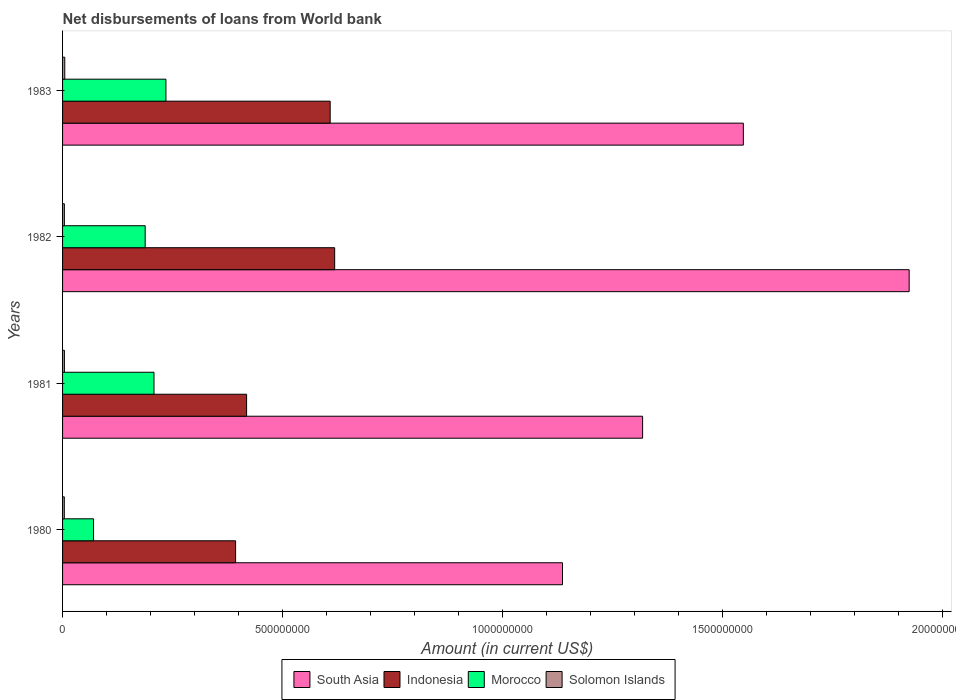What is the amount of loan disbursed from World Bank in Indonesia in 1980?
Provide a short and direct response. 3.93e+08. Across all years, what is the maximum amount of loan disbursed from World Bank in South Asia?
Ensure brevity in your answer.  1.92e+09. Across all years, what is the minimum amount of loan disbursed from World Bank in Indonesia?
Give a very brief answer. 3.93e+08. In which year was the amount of loan disbursed from World Bank in Morocco minimum?
Provide a short and direct response. 1980. What is the total amount of loan disbursed from World Bank in Morocco in the graph?
Give a very brief answer. 7.01e+08. What is the difference between the amount of loan disbursed from World Bank in Solomon Islands in 1981 and that in 1982?
Your answer should be compact. 6.50e+04. What is the difference between the amount of loan disbursed from World Bank in Morocco in 1981 and the amount of loan disbursed from World Bank in South Asia in 1980?
Provide a short and direct response. -9.28e+08. What is the average amount of loan disbursed from World Bank in South Asia per year?
Your response must be concise. 1.48e+09. In the year 1981, what is the difference between the amount of loan disbursed from World Bank in Indonesia and amount of loan disbursed from World Bank in South Asia?
Provide a succinct answer. -9.00e+08. What is the ratio of the amount of loan disbursed from World Bank in Solomon Islands in 1980 to that in 1982?
Provide a short and direct response. 0.96. Is the amount of loan disbursed from World Bank in Morocco in 1980 less than that in 1981?
Your response must be concise. Yes. Is the difference between the amount of loan disbursed from World Bank in Indonesia in 1981 and 1982 greater than the difference between the amount of loan disbursed from World Bank in South Asia in 1981 and 1982?
Provide a short and direct response. Yes. What is the difference between the highest and the second highest amount of loan disbursed from World Bank in Indonesia?
Ensure brevity in your answer.  1.02e+07. What is the difference between the highest and the lowest amount of loan disbursed from World Bank in South Asia?
Offer a terse response. 7.88e+08. What does the 4th bar from the top in 1983 represents?
Provide a short and direct response. South Asia. What does the 4th bar from the bottom in 1982 represents?
Provide a succinct answer. Solomon Islands. Is it the case that in every year, the sum of the amount of loan disbursed from World Bank in Solomon Islands and amount of loan disbursed from World Bank in Morocco is greater than the amount of loan disbursed from World Bank in South Asia?
Ensure brevity in your answer.  No. How many years are there in the graph?
Give a very brief answer. 4. Where does the legend appear in the graph?
Keep it short and to the point. Bottom center. What is the title of the graph?
Offer a terse response. Net disbursements of loans from World bank. Does "Sub-Saharan Africa (all income levels)" appear as one of the legend labels in the graph?
Your answer should be compact. No. What is the Amount (in current US$) of South Asia in 1980?
Give a very brief answer. 1.14e+09. What is the Amount (in current US$) of Indonesia in 1980?
Your answer should be very brief. 3.93e+08. What is the Amount (in current US$) of Morocco in 1980?
Provide a short and direct response. 7.03e+07. What is the Amount (in current US$) in Solomon Islands in 1980?
Make the answer very short. 3.96e+06. What is the Amount (in current US$) in South Asia in 1981?
Offer a very short reply. 1.32e+09. What is the Amount (in current US$) in Indonesia in 1981?
Provide a succinct answer. 4.18e+08. What is the Amount (in current US$) of Morocco in 1981?
Your response must be concise. 2.08e+08. What is the Amount (in current US$) of Solomon Islands in 1981?
Your response must be concise. 4.18e+06. What is the Amount (in current US$) of South Asia in 1982?
Your answer should be very brief. 1.92e+09. What is the Amount (in current US$) in Indonesia in 1982?
Make the answer very short. 6.18e+08. What is the Amount (in current US$) of Morocco in 1982?
Keep it short and to the point. 1.88e+08. What is the Amount (in current US$) in Solomon Islands in 1982?
Make the answer very short. 4.12e+06. What is the Amount (in current US$) in South Asia in 1983?
Your answer should be very brief. 1.55e+09. What is the Amount (in current US$) of Indonesia in 1983?
Your answer should be compact. 6.08e+08. What is the Amount (in current US$) of Morocco in 1983?
Keep it short and to the point. 2.35e+08. What is the Amount (in current US$) in Solomon Islands in 1983?
Provide a short and direct response. 5.01e+06. Across all years, what is the maximum Amount (in current US$) of South Asia?
Keep it short and to the point. 1.92e+09. Across all years, what is the maximum Amount (in current US$) in Indonesia?
Make the answer very short. 6.18e+08. Across all years, what is the maximum Amount (in current US$) in Morocco?
Offer a terse response. 2.35e+08. Across all years, what is the maximum Amount (in current US$) in Solomon Islands?
Ensure brevity in your answer.  5.01e+06. Across all years, what is the minimum Amount (in current US$) of South Asia?
Provide a succinct answer. 1.14e+09. Across all years, what is the minimum Amount (in current US$) of Indonesia?
Provide a short and direct response. 3.93e+08. Across all years, what is the minimum Amount (in current US$) in Morocco?
Ensure brevity in your answer.  7.03e+07. Across all years, what is the minimum Amount (in current US$) of Solomon Islands?
Your answer should be compact. 3.96e+06. What is the total Amount (in current US$) of South Asia in the graph?
Provide a short and direct response. 5.93e+09. What is the total Amount (in current US$) of Indonesia in the graph?
Give a very brief answer. 2.04e+09. What is the total Amount (in current US$) of Morocco in the graph?
Keep it short and to the point. 7.01e+08. What is the total Amount (in current US$) in Solomon Islands in the graph?
Keep it short and to the point. 1.73e+07. What is the difference between the Amount (in current US$) in South Asia in 1980 and that in 1981?
Ensure brevity in your answer.  -1.82e+08. What is the difference between the Amount (in current US$) of Indonesia in 1980 and that in 1981?
Give a very brief answer. -2.49e+07. What is the difference between the Amount (in current US$) of Morocco in 1980 and that in 1981?
Ensure brevity in your answer.  -1.37e+08. What is the difference between the Amount (in current US$) of Solomon Islands in 1980 and that in 1981?
Make the answer very short. -2.23e+05. What is the difference between the Amount (in current US$) of South Asia in 1980 and that in 1982?
Keep it short and to the point. -7.88e+08. What is the difference between the Amount (in current US$) of Indonesia in 1980 and that in 1982?
Give a very brief answer. -2.25e+08. What is the difference between the Amount (in current US$) of Morocco in 1980 and that in 1982?
Offer a very short reply. -1.17e+08. What is the difference between the Amount (in current US$) in Solomon Islands in 1980 and that in 1982?
Ensure brevity in your answer.  -1.58e+05. What is the difference between the Amount (in current US$) in South Asia in 1980 and that in 1983?
Provide a short and direct response. -4.11e+08. What is the difference between the Amount (in current US$) in Indonesia in 1980 and that in 1983?
Make the answer very short. -2.15e+08. What is the difference between the Amount (in current US$) of Morocco in 1980 and that in 1983?
Your answer should be compact. -1.65e+08. What is the difference between the Amount (in current US$) of Solomon Islands in 1980 and that in 1983?
Provide a short and direct response. -1.05e+06. What is the difference between the Amount (in current US$) of South Asia in 1981 and that in 1982?
Offer a very short reply. -6.06e+08. What is the difference between the Amount (in current US$) of Indonesia in 1981 and that in 1982?
Offer a terse response. -2.00e+08. What is the difference between the Amount (in current US$) of Morocco in 1981 and that in 1982?
Offer a terse response. 2.01e+07. What is the difference between the Amount (in current US$) in Solomon Islands in 1981 and that in 1982?
Offer a terse response. 6.50e+04. What is the difference between the Amount (in current US$) in South Asia in 1981 and that in 1983?
Offer a very short reply. -2.29e+08. What is the difference between the Amount (in current US$) in Indonesia in 1981 and that in 1983?
Your response must be concise. -1.90e+08. What is the difference between the Amount (in current US$) of Morocco in 1981 and that in 1983?
Give a very brief answer. -2.71e+07. What is the difference between the Amount (in current US$) in Solomon Islands in 1981 and that in 1983?
Offer a very short reply. -8.31e+05. What is the difference between the Amount (in current US$) in South Asia in 1982 and that in 1983?
Make the answer very short. 3.77e+08. What is the difference between the Amount (in current US$) in Indonesia in 1982 and that in 1983?
Provide a short and direct response. 1.02e+07. What is the difference between the Amount (in current US$) of Morocco in 1982 and that in 1983?
Your answer should be compact. -4.72e+07. What is the difference between the Amount (in current US$) in Solomon Islands in 1982 and that in 1983?
Give a very brief answer. -8.96e+05. What is the difference between the Amount (in current US$) in South Asia in 1980 and the Amount (in current US$) in Indonesia in 1981?
Give a very brief answer. 7.18e+08. What is the difference between the Amount (in current US$) of South Asia in 1980 and the Amount (in current US$) of Morocco in 1981?
Provide a short and direct response. 9.28e+08. What is the difference between the Amount (in current US$) of South Asia in 1980 and the Amount (in current US$) of Solomon Islands in 1981?
Offer a terse response. 1.13e+09. What is the difference between the Amount (in current US$) in Indonesia in 1980 and the Amount (in current US$) in Morocco in 1981?
Make the answer very short. 1.85e+08. What is the difference between the Amount (in current US$) of Indonesia in 1980 and the Amount (in current US$) of Solomon Islands in 1981?
Your answer should be very brief. 3.89e+08. What is the difference between the Amount (in current US$) in Morocco in 1980 and the Amount (in current US$) in Solomon Islands in 1981?
Offer a terse response. 6.62e+07. What is the difference between the Amount (in current US$) of South Asia in 1980 and the Amount (in current US$) of Indonesia in 1982?
Offer a very short reply. 5.18e+08. What is the difference between the Amount (in current US$) of South Asia in 1980 and the Amount (in current US$) of Morocco in 1982?
Your answer should be compact. 9.48e+08. What is the difference between the Amount (in current US$) in South Asia in 1980 and the Amount (in current US$) in Solomon Islands in 1982?
Your answer should be very brief. 1.13e+09. What is the difference between the Amount (in current US$) of Indonesia in 1980 and the Amount (in current US$) of Morocco in 1982?
Give a very brief answer. 2.06e+08. What is the difference between the Amount (in current US$) of Indonesia in 1980 and the Amount (in current US$) of Solomon Islands in 1982?
Give a very brief answer. 3.89e+08. What is the difference between the Amount (in current US$) of Morocco in 1980 and the Amount (in current US$) of Solomon Islands in 1982?
Your response must be concise. 6.62e+07. What is the difference between the Amount (in current US$) in South Asia in 1980 and the Amount (in current US$) in Indonesia in 1983?
Keep it short and to the point. 5.28e+08. What is the difference between the Amount (in current US$) of South Asia in 1980 and the Amount (in current US$) of Morocco in 1983?
Your answer should be compact. 9.01e+08. What is the difference between the Amount (in current US$) in South Asia in 1980 and the Amount (in current US$) in Solomon Islands in 1983?
Provide a short and direct response. 1.13e+09. What is the difference between the Amount (in current US$) of Indonesia in 1980 and the Amount (in current US$) of Morocco in 1983?
Make the answer very short. 1.58e+08. What is the difference between the Amount (in current US$) of Indonesia in 1980 and the Amount (in current US$) of Solomon Islands in 1983?
Ensure brevity in your answer.  3.88e+08. What is the difference between the Amount (in current US$) of Morocco in 1980 and the Amount (in current US$) of Solomon Islands in 1983?
Keep it short and to the point. 6.53e+07. What is the difference between the Amount (in current US$) in South Asia in 1981 and the Amount (in current US$) in Indonesia in 1982?
Give a very brief answer. 7.00e+08. What is the difference between the Amount (in current US$) of South Asia in 1981 and the Amount (in current US$) of Morocco in 1982?
Your answer should be very brief. 1.13e+09. What is the difference between the Amount (in current US$) of South Asia in 1981 and the Amount (in current US$) of Solomon Islands in 1982?
Keep it short and to the point. 1.31e+09. What is the difference between the Amount (in current US$) in Indonesia in 1981 and the Amount (in current US$) in Morocco in 1982?
Your answer should be compact. 2.30e+08. What is the difference between the Amount (in current US$) in Indonesia in 1981 and the Amount (in current US$) in Solomon Islands in 1982?
Provide a short and direct response. 4.14e+08. What is the difference between the Amount (in current US$) in Morocco in 1981 and the Amount (in current US$) in Solomon Islands in 1982?
Provide a succinct answer. 2.04e+08. What is the difference between the Amount (in current US$) in South Asia in 1981 and the Amount (in current US$) in Indonesia in 1983?
Offer a terse response. 7.10e+08. What is the difference between the Amount (in current US$) in South Asia in 1981 and the Amount (in current US$) in Morocco in 1983?
Make the answer very short. 1.08e+09. What is the difference between the Amount (in current US$) of South Asia in 1981 and the Amount (in current US$) of Solomon Islands in 1983?
Make the answer very short. 1.31e+09. What is the difference between the Amount (in current US$) in Indonesia in 1981 and the Amount (in current US$) in Morocco in 1983?
Keep it short and to the point. 1.83e+08. What is the difference between the Amount (in current US$) of Indonesia in 1981 and the Amount (in current US$) of Solomon Islands in 1983?
Your answer should be compact. 4.13e+08. What is the difference between the Amount (in current US$) in Morocco in 1981 and the Amount (in current US$) in Solomon Islands in 1983?
Offer a terse response. 2.03e+08. What is the difference between the Amount (in current US$) of South Asia in 1982 and the Amount (in current US$) of Indonesia in 1983?
Your answer should be very brief. 1.32e+09. What is the difference between the Amount (in current US$) of South Asia in 1982 and the Amount (in current US$) of Morocco in 1983?
Make the answer very short. 1.69e+09. What is the difference between the Amount (in current US$) of South Asia in 1982 and the Amount (in current US$) of Solomon Islands in 1983?
Your response must be concise. 1.92e+09. What is the difference between the Amount (in current US$) in Indonesia in 1982 and the Amount (in current US$) in Morocco in 1983?
Provide a short and direct response. 3.83e+08. What is the difference between the Amount (in current US$) in Indonesia in 1982 and the Amount (in current US$) in Solomon Islands in 1983?
Keep it short and to the point. 6.13e+08. What is the difference between the Amount (in current US$) in Morocco in 1982 and the Amount (in current US$) in Solomon Islands in 1983?
Ensure brevity in your answer.  1.83e+08. What is the average Amount (in current US$) of South Asia per year?
Provide a short and direct response. 1.48e+09. What is the average Amount (in current US$) in Indonesia per year?
Offer a terse response. 5.09e+08. What is the average Amount (in current US$) in Morocco per year?
Your response must be concise. 1.75e+08. What is the average Amount (in current US$) in Solomon Islands per year?
Provide a succinct answer. 4.32e+06. In the year 1980, what is the difference between the Amount (in current US$) of South Asia and Amount (in current US$) of Indonesia?
Offer a terse response. 7.43e+08. In the year 1980, what is the difference between the Amount (in current US$) in South Asia and Amount (in current US$) in Morocco?
Offer a terse response. 1.07e+09. In the year 1980, what is the difference between the Amount (in current US$) in South Asia and Amount (in current US$) in Solomon Islands?
Make the answer very short. 1.13e+09. In the year 1980, what is the difference between the Amount (in current US$) in Indonesia and Amount (in current US$) in Morocco?
Offer a terse response. 3.23e+08. In the year 1980, what is the difference between the Amount (in current US$) of Indonesia and Amount (in current US$) of Solomon Islands?
Make the answer very short. 3.89e+08. In the year 1980, what is the difference between the Amount (in current US$) of Morocco and Amount (in current US$) of Solomon Islands?
Offer a very short reply. 6.64e+07. In the year 1981, what is the difference between the Amount (in current US$) of South Asia and Amount (in current US$) of Indonesia?
Your answer should be very brief. 9.00e+08. In the year 1981, what is the difference between the Amount (in current US$) in South Asia and Amount (in current US$) in Morocco?
Give a very brief answer. 1.11e+09. In the year 1981, what is the difference between the Amount (in current US$) of South Asia and Amount (in current US$) of Solomon Islands?
Provide a succinct answer. 1.31e+09. In the year 1981, what is the difference between the Amount (in current US$) in Indonesia and Amount (in current US$) in Morocco?
Offer a terse response. 2.10e+08. In the year 1981, what is the difference between the Amount (in current US$) in Indonesia and Amount (in current US$) in Solomon Islands?
Provide a succinct answer. 4.14e+08. In the year 1981, what is the difference between the Amount (in current US$) in Morocco and Amount (in current US$) in Solomon Islands?
Make the answer very short. 2.04e+08. In the year 1982, what is the difference between the Amount (in current US$) of South Asia and Amount (in current US$) of Indonesia?
Your response must be concise. 1.31e+09. In the year 1982, what is the difference between the Amount (in current US$) in South Asia and Amount (in current US$) in Morocco?
Provide a succinct answer. 1.74e+09. In the year 1982, what is the difference between the Amount (in current US$) in South Asia and Amount (in current US$) in Solomon Islands?
Your answer should be very brief. 1.92e+09. In the year 1982, what is the difference between the Amount (in current US$) in Indonesia and Amount (in current US$) in Morocco?
Your answer should be very brief. 4.31e+08. In the year 1982, what is the difference between the Amount (in current US$) in Indonesia and Amount (in current US$) in Solomon Islands?
Offer a terse response. 6.14e+08. In the year 1982, what is the difference between the Amount (in current US$) of Morocco and Amount (in current US$) of Solomon Islands?
Offer a very short reply. 1.84e+08. In the year 1983, what is the difference between the Amount (in current US$) of South Asia and Amount (in current US$) of Indonesia?
Offer a terse response. 9.39e+08. In the year 1983, what is the difference between the Amount (in current US$) in South Asia and Amount (in current US$) in Morocco?
Make the answer very short. 1.31e+09. In the year 1983, what is the difference between the Amount (in current US$) of South Asia and Amount (in current US$) of Solomon Islands?
Offer a very short reply. 1.54e+09. In the year 1983, what is the difference between the Amount (in current US$) in Indonesia and Amount (in current US$) in Morocco?
Provide a short and direct response. 3.73e+08. In the year 1983, what is the difference between the Amount (in current US$) of Indonesia and Amount (in current US$) of Solomon Islands?
Your answer should be very brief. 6.03e+08. In the year 1983, what is the difference between the Amount (in current US$) of Morocco and Amount (in current US$) of Solomon Islands?
Make the answer very short. 2.30e+08. What is the ratio of the Amount (in current US$) of South Asia in 1980 to that in 1981?
Your answer should be compact. 0.86. What is the ratio of the Amount (in current US$) in Indonesia in 1980 to that in 1981?
Provide a succinct answer. 0.94. What is the ratio of the Amount (in current US$) in Morocco in 1980 to that in 1981?
Your answer should be compact. 0.34. What is the ratio of the Amount (in current US$) in Solomon Islands in 1980 to that in 1981?
Ensure brevity in your answer.  0.95. What is the ratio of the Amount (in current US$) of South Asia in 1980 to that in 1982?
Provide a short and direct response. 0.59. What is the ratio of the Amount (in current US$) of Indonesia in 1980 to that in 1982?
Your answer should be compact. 0.64. What is the ratio of the Amount (in current US$) in Morocco in 1980 to that in 1982?
Keep it short and to the point. 0.37. What is the ratio of the Amount (in current US$) of Solomon Islands in 1980 to that in 1982?
Provide a succinct answer. 0.96. What is the ratio of the Amount (in current US$) of South Asia in 1980 to that in 1983?
Offer a very short reply. 0.73. What is the ratio of the Amount (in current US$) in Indonesia in 1980 to that in 1983?
Give a very brief answer. 0.65. What is the ratio of the Amount (in current US$) of Morocco in 1980 to that in 1983?
Your response must be concise. 0.3. What is the ratio of the Amount (in current US$) in Solomon Islands in 1980 to that in 1983?
Provide a succinct answer. 0.79. What is the ratio of the Amount (in current US$) of South Asia in 1981 to that in 1982?
Your response must be concise. 0.69. What is the ratio of the Amount (in current US$) in Indonesia in 1981 to that in 1982?
Offer a very short reply. 0.68. What is the ratio of the Amount (in current US$) of Morocco in 1981 to that in 1982?
Offer a terse response. 1.11. What is the ratio of the Amount (in current US$) in Solomon Islands in 1981 to that in 1982?
Give a very brief answer. 1.02. What is the ratio of the Amount (in current US$) of South Asia in 1981 to that in 1983?
Your answer should be compact. 0.85. What is the ratio of the Amount (in current US$) of Indonesia in 1981 to that in 1983?
Offer a very short reply. 0.69. What is the ratio of the Amount (in current US$) in Morocco in 1981 to that in 1983?
Give a very brief answer. 0.88. What is the ratio of the Amount (in current US$) of Solomon Islands in 1981 to that in 1983?
Provide a short and direct response. 0.83. What is the ratio of the Amount (in current US$) in South Asia in 1982 to that in 1983?
Your answer should be compact. 1.24. What is the ratio of the Amount (in current US$) of Indonesia in 1982 to that in 1983?
Your answer should be very brief. 1.02. What is the ratio of the Amount (in current US$) in Morocco in 1982 to that in 1983?
Keep it short and to the point. 0.8. What is the ratio of the Amount (in current US$) in Solomon Islands in 1982 to that in 1983?
Ensure brevity in your answer.  0.82. What is the difference between the highest and the second highest Amount (in current US$) in South Asia?
Keep it short and to the point. 3.77e+08. What is the difference between the highest and the second highest Amount (in current US$) in Indonesia?
Keep it short and to the point. 1.02e+07. What is the difference between the highest and the second highest Amount (in current US$) in Morocco?
Provide a succinct answer. 2.71e+07. What is the difference between the highest and the second highest Amount (in current US$) in Solomon Islands?
Your answer should be compact. 8.31e+05. What is the difference between the highest and the lowest Amount (in current US$) of South Asia?
Your answer should be compact. 7.88e+08. What is the difference between the highest and the lowest Amount (in current US$) of Indonesia?
Keep it short and to the point. 2.25e+08. What is the difference between the highest and the lowest Amount (in current US$) of Morocco?
Ensure brevity in your answer.  1.65e+08. What is the difference between the highest and the lowest Amount (in current US$) in Solomon Islands?
Your response must be concise. 1.05e+06. 